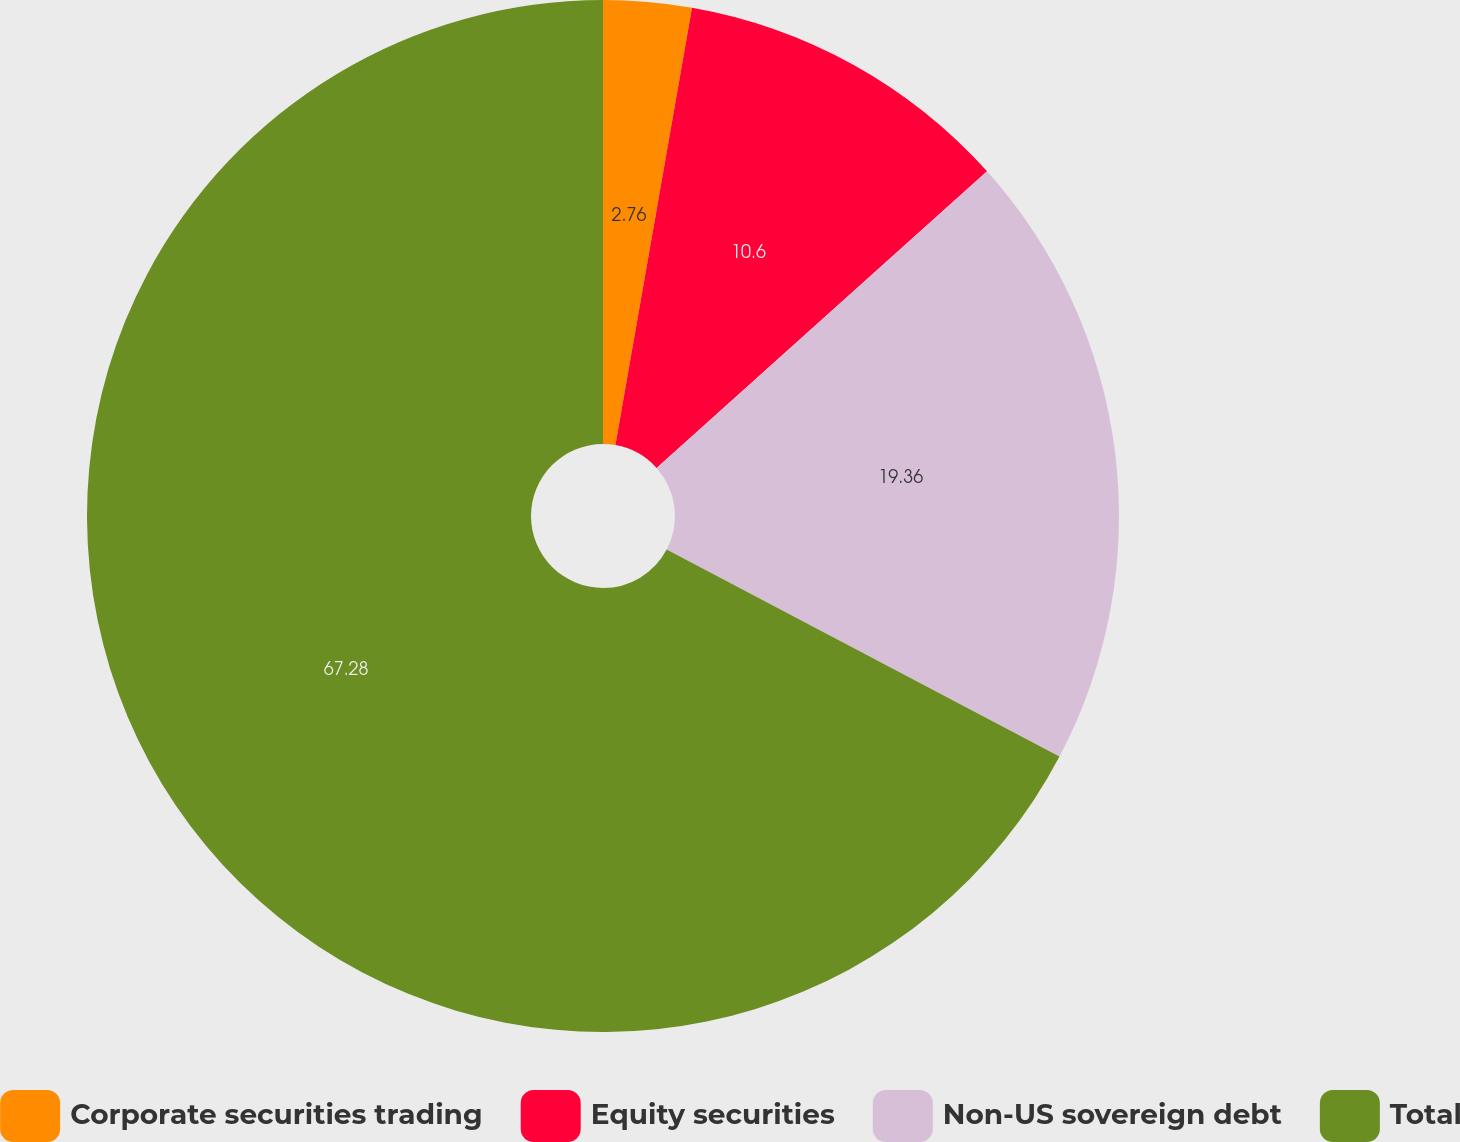<chart> <loc_0><loc_0><loc_500><loc_500><pie_chart><fcel>Corporate securities trading<fcel>Equity securities<fcel>Non-US sovereign debt<fcel>Total<nl><fcel>2.76%<fcel>10.6%<fcel>19.36%<fcel>67.28%<nl></chart> 